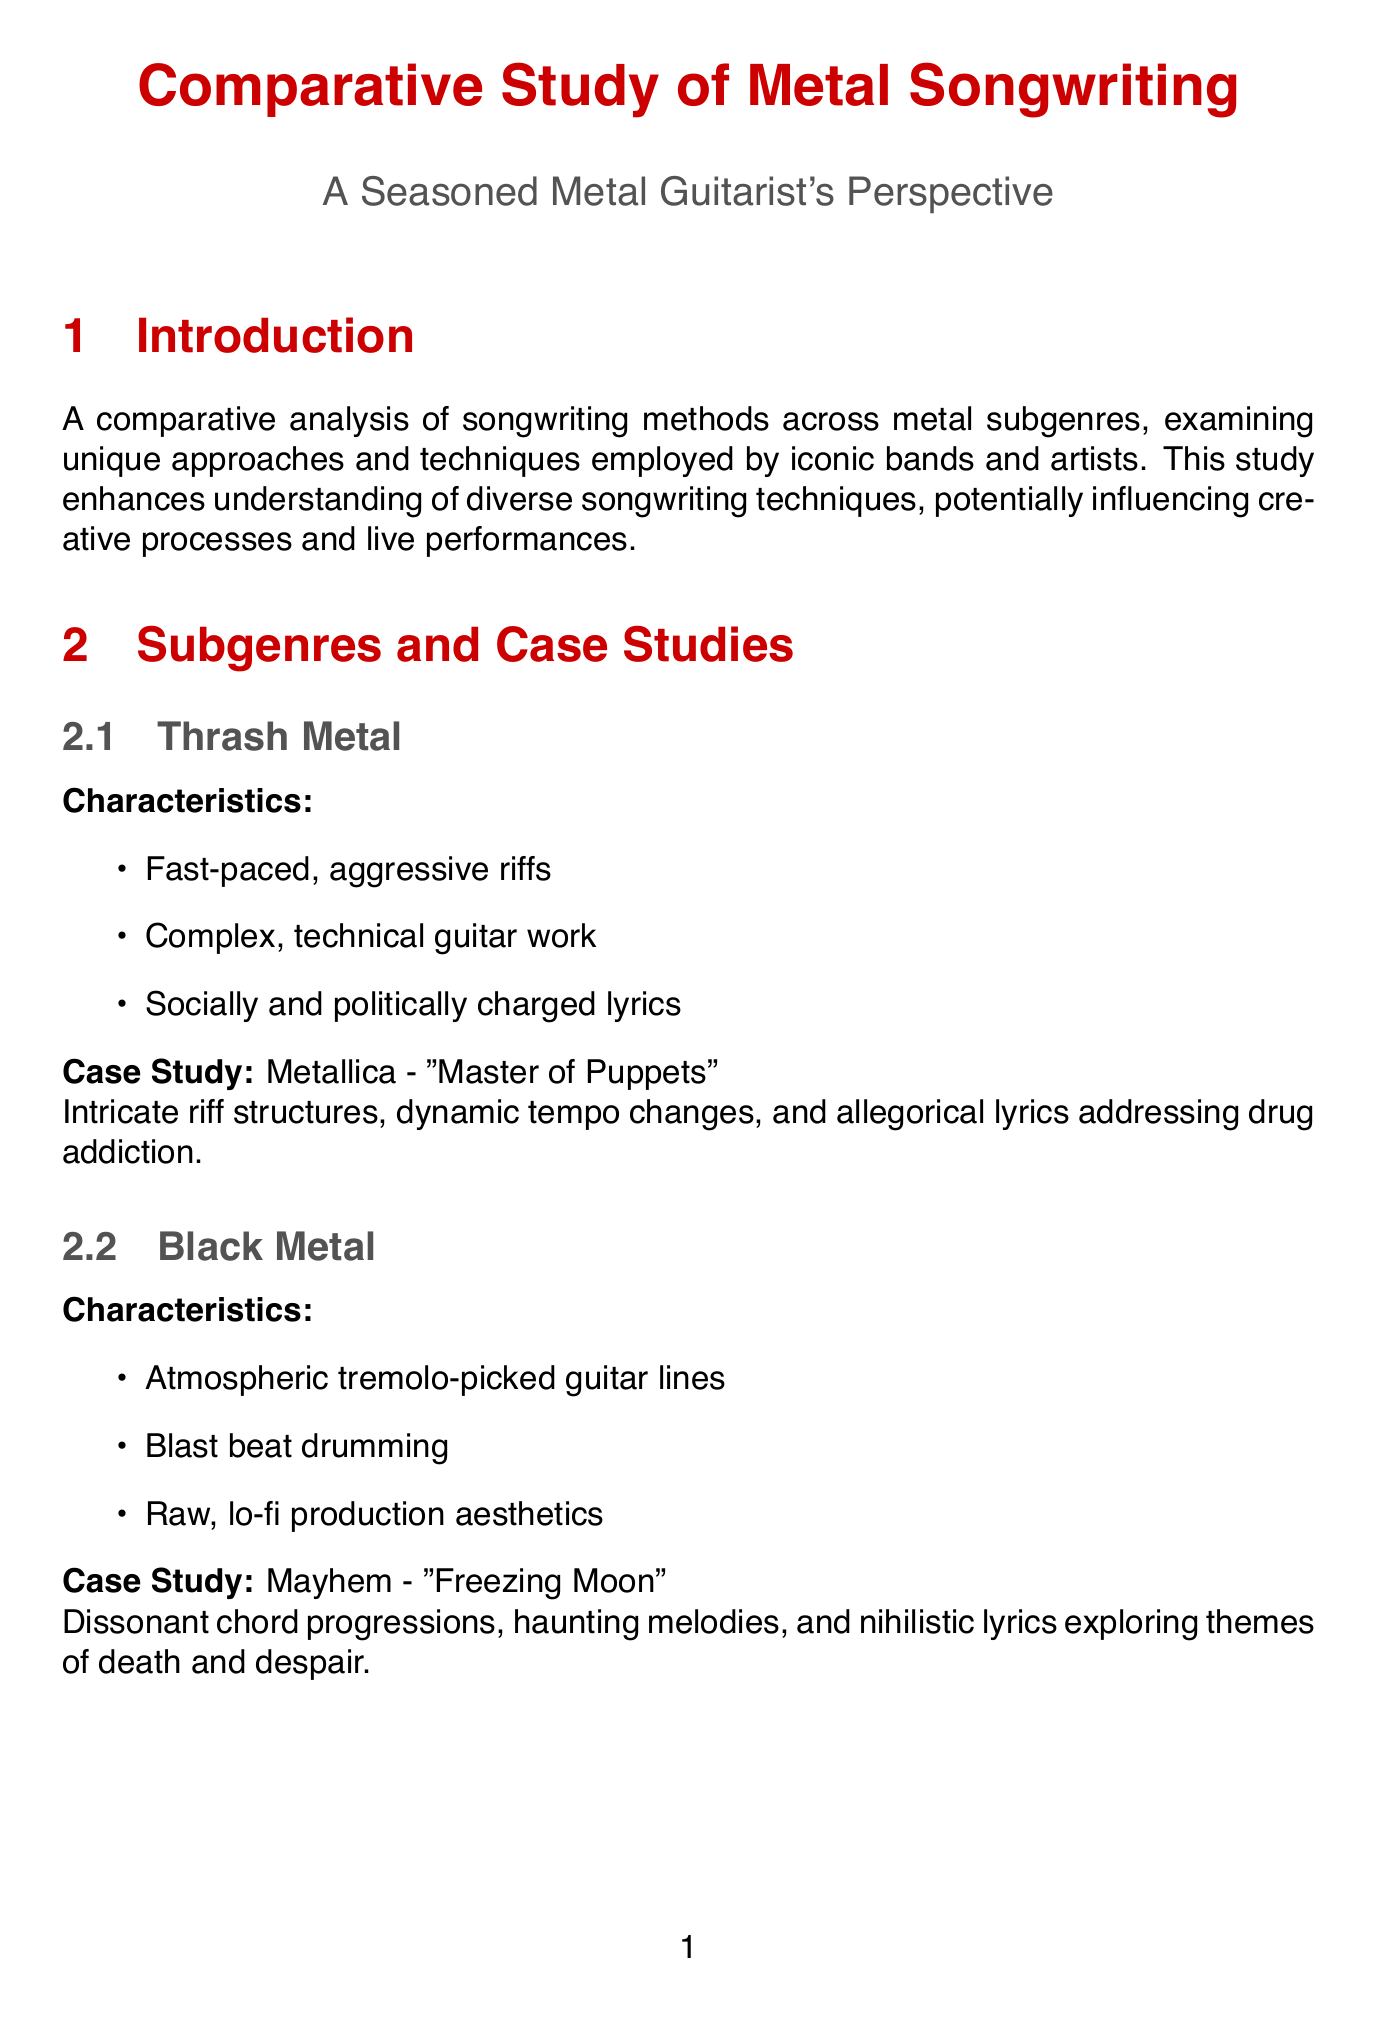What subgenre does Metallica represent? The document states Metallica is associated with Thrash Metal.
Answer: Thrash Metal What is a prominent technique used in Progressive Metal? The document highlights "Melodic counterpoint" as a technique common in Progressive Metal.
Answer: Melodic counterpoint Which band is associated with the track "Freezing Moon"? The case study in the document identifies Mayhem as the band for "Freezing Moon."
Answer: Mayhem What lyrical theme explores ancient myths? The document mentions "Mythology and fantasy" as a theme that draws from ancient myths.
Answer: Mythology and fantasy What is a key finding about metal songwriting methods? One of the key findings states that songwriting methods vary significantly across metal subgenres.
Answer: Varied significantly What song does the technique "Riff-based composition" prominently feature? The document gives Pantera's "Walk" as an example of "Riff-based composition."
Answer: Walk How is Doom Metal characterized musically? The document describes Doom Metal as having slow tempos and heavy, down-tuned riffs.
Answer: Slow tempos and heavy, down-tuned riffs What is the focus of the analysis presented in the document? The document provides a comparative analysis of songwriting methods across metal subgenres.
Answer: Comparative analysis What do diverse songwriting approaches enhance for musicians? Understanding diverse songwriting approaches can enhance a musician's versatility and creativity.
Answer: Versatility and creativity 